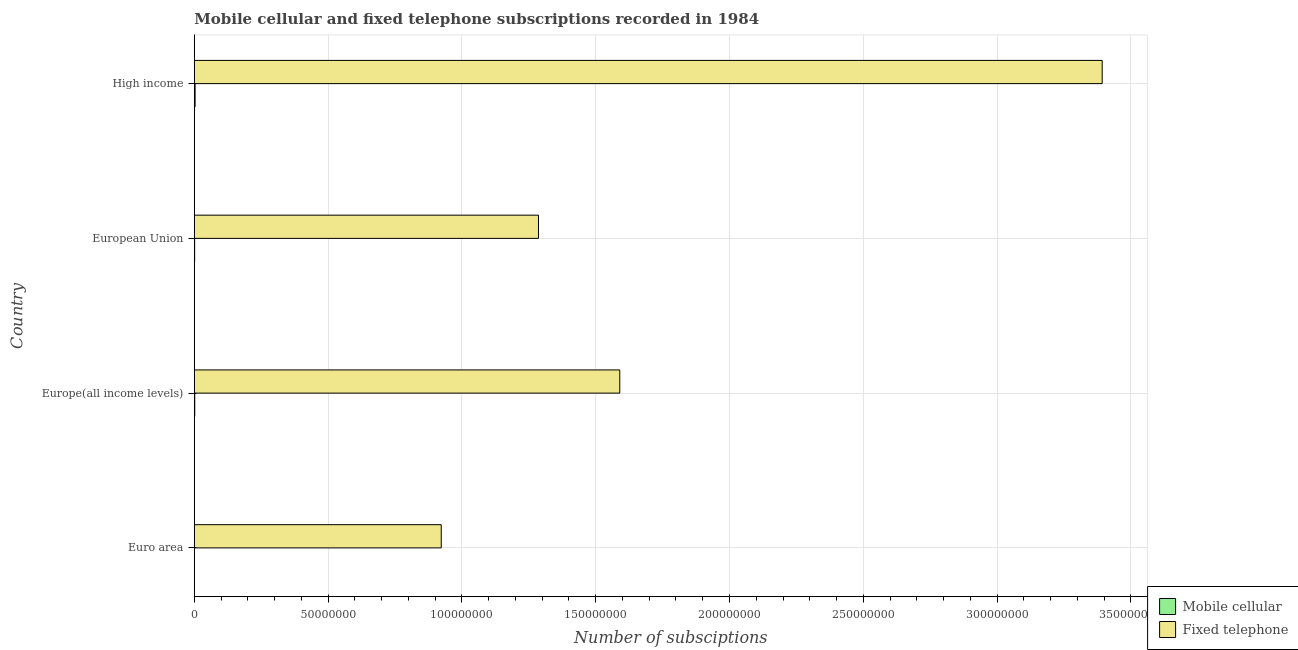How many different coloured bars are there?
Your response must be concise. 2. Are the number of bars per tick equal to the number of legend labels?
Offer a terse response. Yes. How many bars are there on the 1st tick from the top?
Give a very brief answer. 2. How many bars are there on the 4th tick from the bottom?
Your answer should be very brief. 2. What is the number of fixed telephone subscriptions in European Union?
Make the answer very short. 1.29e+08. Across all countries, what is the maximum number of mobile cellular subscriptions?
Keep it short and to the point. 3.18e+05. Across all countries, what is the minimum number of fixed telephone subscriptions?
Your answer should be compact. 9.23e+07. What is the total number of fixed telephone subscriptions in the graph?
Make the answer very short. 7.19e+08. What is the difference between the number of mobile cellular subscriptions in Euro area and that in High income?
Ensure brevity in your answer.  -2.65e+05. What is the difference between the number of mobile cellular subscriptions in High income and the number of fixed telephone subscriptions in Europe(all income levels)?
Your answer should be very brief. -1.59e+08. What is the average number of mobile cellular subscriptions per country?
Ensure brevity in your answer.  1.72e+05. What is the difference between the number of fixed telephone subscriptions and number of mobile cellular subscriptions in Euro area?
Ensure brevity in your answer.  9.22e+07. In how many countries, is the number of mobile cellular subscriptions greater than 140000000 ?
Provide a succinct answer. 0. What is the ratio of the number of fixed telephone subscriptions in Euro area to that in High income?
Your response must be concise. 0.27. Is the number of mobile cellular subscriptions in Euro area less than that in European Union?
Give a very brief answer. Yes. What is the difference between the highest and the second highest number of mobile cellular subscriptions?
Your answer should be compact. 1.38e+05. What is the difference between the highest and the lowest number of mobile cellular subscriptions?
Provide a succinct answer. 2.65e+05. Is the sum of the number of mobile cellular subscriptions in European Union and High income greater than the maximum number of fixed telephone subscriptions across all countries?
Keep it short and to the point. No. What does the 1st bar from the top in Euro area represents?
Give a very brief answer. Fixed telephone. What does the 1st bar from the bottom in European Union represents?
Your answer should be compact. Mobile cellular. Does the graph contain any zero values?
Give a very brief answer. No. Does the graph contain grids?
Your response must be concise. Yes. Where does the legend appear in the graph?
Offer a very short reply. Bottom right. How many legend labels are there?
Your response must be concise. 2. What is the title of the graph?
Ensure brevity in your answer.  Mobile cellular and fixed telephone subscriptions recorded in 1984. Does "Food" appear as one of the legend labels in the graph?
Provide a succinct answer. No. What is the label or title of the X-axis?
Make the answer very short. Number of subsciptions. What is the label or title of the Y-axis?
Give a very brief answer. Country. What is the Number of subsciptions of Mobile cellular in Euro area?
Keep it short and to the point. 5.20e+04. What is the Number of subsciptions of Fixed telephone in Euro area?
Your response must be concise. 9.23e+07. What is the Number of subsciptions in Mobile cellular in Europe(all income levels)?
Give a very brief answer. 1.80e+05. What is the Number of subsciptions in Fixed telephone in Europe(all income levels)?
Provide a short and direct response. 1.59e+08. What is the Number of subsciptions in Mobile cellular in European Union?
Make the answer very short. 1.41e+05. What is the Number of subsciptions of Fixed telephone in European Union?
Give a very brief answer. 1.29e+08. What is the Number of subsciptions of Mobile cellular in High income?
Provide a succinct answer. 3.18e+05. What is the Number of subsciptions in Fixed telephone in High income?
Your response must be concise. 3.39e+08. Across all countries, what is the maximum Number of subsciptions in Mobile cellular?
Your answer should be very brief. 3.18e+05. Across all countries, what is the maximum Number of subsciptions in Fixed telephone?
Keep it short and to the point. 3.39e+08. Across all countries, what is the minimum Number of subsciptions in Mobile cellular?
Provide a succinct answer. 5.20e+04. Across all countries, what is the minimum Number of subsciptions in Fixed telephone?
Provide a short and direct response. 9.23e+07. What is the total Number of subsciptions of Mobile cellular in the graph?
Provide a succinct answer. 6.90e+05. What is the total Number of subsciptions in Fixed telephone in the graph?
Keep it short and to the point. 7.19e+08. What is the difference between the Number of subsciptions of Mobile cellular in Euro area and that in Europe(all income levels)?
Your response must be concise. -1.28e+05. What is the difference between the Number of subsciptions in Fixed telephone in Euro area and that in Europe(all income levels)?
Make the answer very short. -6.67e+07. What is the difference between the Number of subsciptions of Mobile cellular in Euro area and that in European Union?
Make the answer very short. -8.85e+04. What is the difference between the Number of subsciptions in Fixed telephone in Euro area and that in European Union?
Offer a terse response. -3.63e+07. What is the difference between the Number of subsciptions of Mobile cellular in Euro area and that in High income?
Ensure brevity in your answer.  -2.65e+05. What is the difference between the Number of subsciptions of Fixed telephone in Euro area and that in High income?
Make the answer very short. -2.47e+08. What is the difference between the Number of subsciptions in Mobile cellular in Europe(all income levels) and that in European Union?
Give a very brief answer. 3.90e+04. What is the difference between the Number of subsciptions in Fixed telephone in Europe(all income levels) and that in European Union?
Your response must be concise. 3.04e+07. What is the difference between the Number of subsciptions in Mobile cellular in Europe(all income levels) and that in High income?
Give a very brief answer. -1.38e+05. What is the difference between the Number of subsciptions of Fixed telephone in Europe(all income levels) and that in High income?
Keep it short and to the point. -1.80e+08. What is the difference between the Number of subsciptions in Mobile cellular in European Union and that in High income?
Your response must be concise. -1.77e+05. What is the difference between the Number of subsciptions in Fixed telephone in European Union and that in High income?
Provide a succinct answer. -2.11e+08. What is the difference between the Number of subsciptions of Mobile cellular in Euro area and the Number of subsciptions of Fixed telephone in Europe(all income levels)?
Make the answer very short. -1.59e+08. What is the difference between the Number of subsciptions of Mobile cellular in Euro area and the Number of subsciptions of Fixed telephone in European Union?
Your response must be concise. -1.29e+08. What is the difference between the Number of subsciptions of Mobile cellular in Euro area and the Number of subsciptions of Fixed telephone in High income?
Make the answer very short. -3.39e+08. What is the difference between the Number of subsciptions of Mobile cellular in Europe(all income levels) and the Number of subsciptions of Fixed telephone in European Union?
Ensure brevity in your answer.  -1.28e+08. What is the difference between the Number of subsciptions in Mobile cellular in Europe(all income levels) and the Number of subsciptions in Fixed telephone in High income?
Offer a terse response. -3.39e+08. What is the difference between the Number of subsciptions of Mobile cellular in European Union and the Number of subsciptions of Fixed telephone in High income?
Your answer should be compact. -3.39e+08. What is the average Number of subsciptions of Mobile cellular per country?
Offer a very short reply. 1.72e+05. What is the average Number of subsciptions in Fixed telephone per country?
Give a very brief answer. 1.80e+08. What is the difference between the Number of subsciptions of Mobile cellular and Number of subsciptions of Fixed telephone in Euro area?
Give a very brief answer. -9.22e+07. What is the difference between the Number of subsciptions of Mobile cellular and Number of subsciptions of Fixed telephone in Europe(all income levels)?
Your answer should be very brief. -1.59e+08. What is the difference between the Number of subsciptions in Mobile cellular and Number of subsciptions in Fixed telephone in European Union?
Provide a short and direct response. -1.28e+08. What is the difference between the Number of subsciptions in Mobile cellular and Number of subsciptions in Fixed telephone in High income?
Keep it short and to the point. -3.39e+08. What is the ratio of the Number of subsciptions in Mobile cellular in Euro area to that in Europe(all income levels)?
Keep it short and to the point. 0.29. What is the ratio of the Number of subsciptions of Fixed telephone in Euro area to that in Europe(all income levels)?
Your answer should be compact. 0.58. What is the ratio of the Number of subsciptions in Mobile cellular in Euro area to that in European Union?
Offer a terse response. 0.37. What is the ratio of the Number of subsciptions of Fixed telephone in Euro area to that in European Union?
Your answer should be very brief. 0.72. What is the ratio of the Number of subsciptions of Mobile cellular in Euro area to that in High income?
Keep it short and to the point. 0.16. What is the ratio of the Number of subsciptions in Fixed telephone in Euro area to that in High income?
Ensure brevity in your answer.  0.27. What is the ratio of the Number of subsciptions of Mobile cellular in Europe(all income levels) to that in European Union?
Your answer should be compact. 1.28. What is the ratio of the Number of subsciptions of Fixed telephone in Europe(all income levels) to that in European Union?
Give a very brief answer. 1.24. What is the ratio of the Number of subsciptions of Mobile cellular in Europe(all income levels) to that in High income?
Offer a terse response. 0.57. What is the ratio of the Number of subsciptions of Fixed telephone in Europe(all income levels) to that in High income?
Ensure brevity in your answer.  0.47. What is the ratio of the Number of subsciptions of Mobile cellular in European Union to that in High income?
Provide a short and direct response. 0.44. What is the ratio of the Number of subsciptions in Fixed telephone in European Union to that in High income?
Your answer should be very brief. 0.38. What is the difference between the highest and the second highest Number of subsciptions in Mobile cellular?
Ensure brevity in your answer.  1.38e+05. What is the difference between the highest and the second highest Number of subsciptions in Fixed telephone?
Give a very brief answer. 1.80e+08. What is the difference between the highest and the lowest Number of subsciptions of Mobile cellular?
Provide a short and direct response. 2.65e+05. What is the difference between the highest and the lowest Number of subsciptions in Fixed telephone?
Keep it short and to the point. 2.47e+08. 